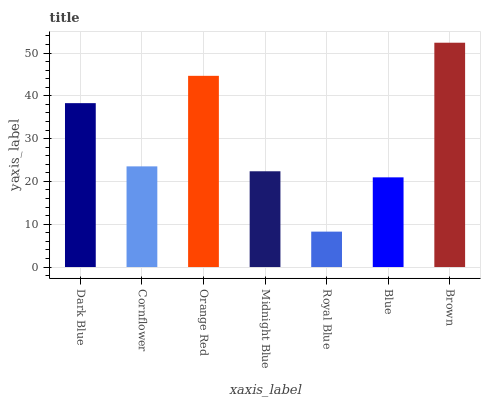Is Royal Blue the minimum?
Answer yes or no. Yes. Is Brown the maximum?
Answer yes or no. Yes. Is Cornflower the minimum?
Answer yes or no. No. Is Cornflower the maximum?
Answer yes or no. No. Is Dark Blue greater than Cornflower?
Answer yes or no. Yes. Is Cornflower less than Dark Blue?
Answer yes or no. Yes. Is Cornflower greater than Dark Blue?
Answer yes or no. No. Is Dark Blue less than Cornflower?
Answer yes or no. No. Is Cornflower the high median?
Answer yes or no. Yes. Is Cornflower the low median?
Answer yes or no. Yes. Is Brown the high median?
Answer yes or no. No. Is Royal Blue the low median?
Answer yes or no. No. 